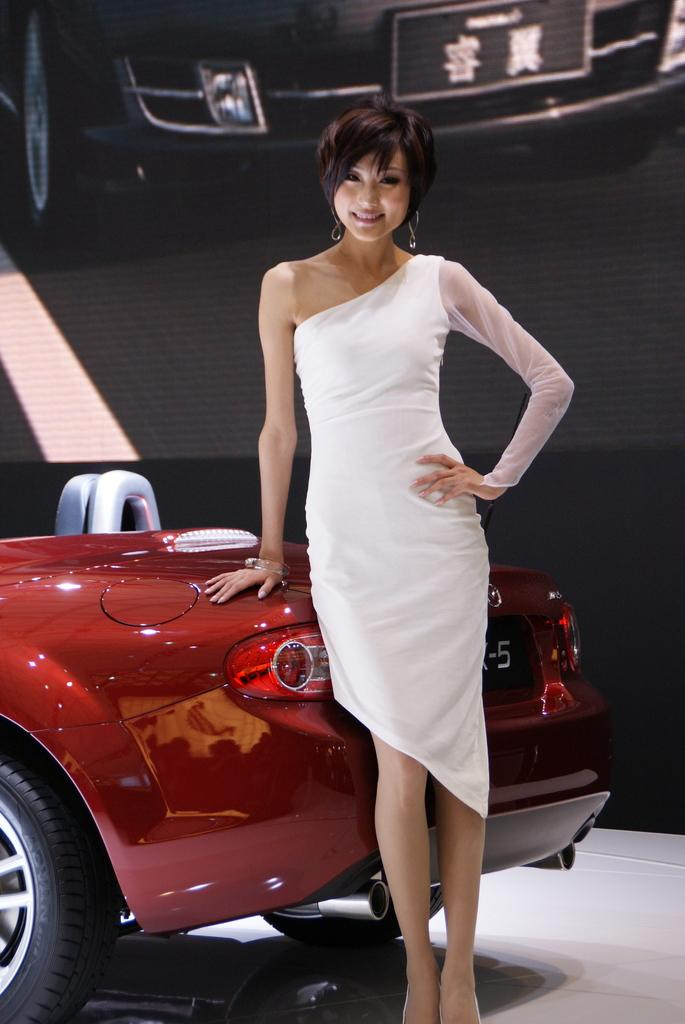Who is in the image? There is a girl in the image. What is the girl doing in the image? The girl is standing beside a car and has her hand on the car. What can be seen in the background of the image? There is a poster of a car in the background of the image. What type of paste is the girl using to stick the horse to the car in the image? There is no paste or horse present in the image; it only features a girl standing beside a car with a poster of a car in the background. 